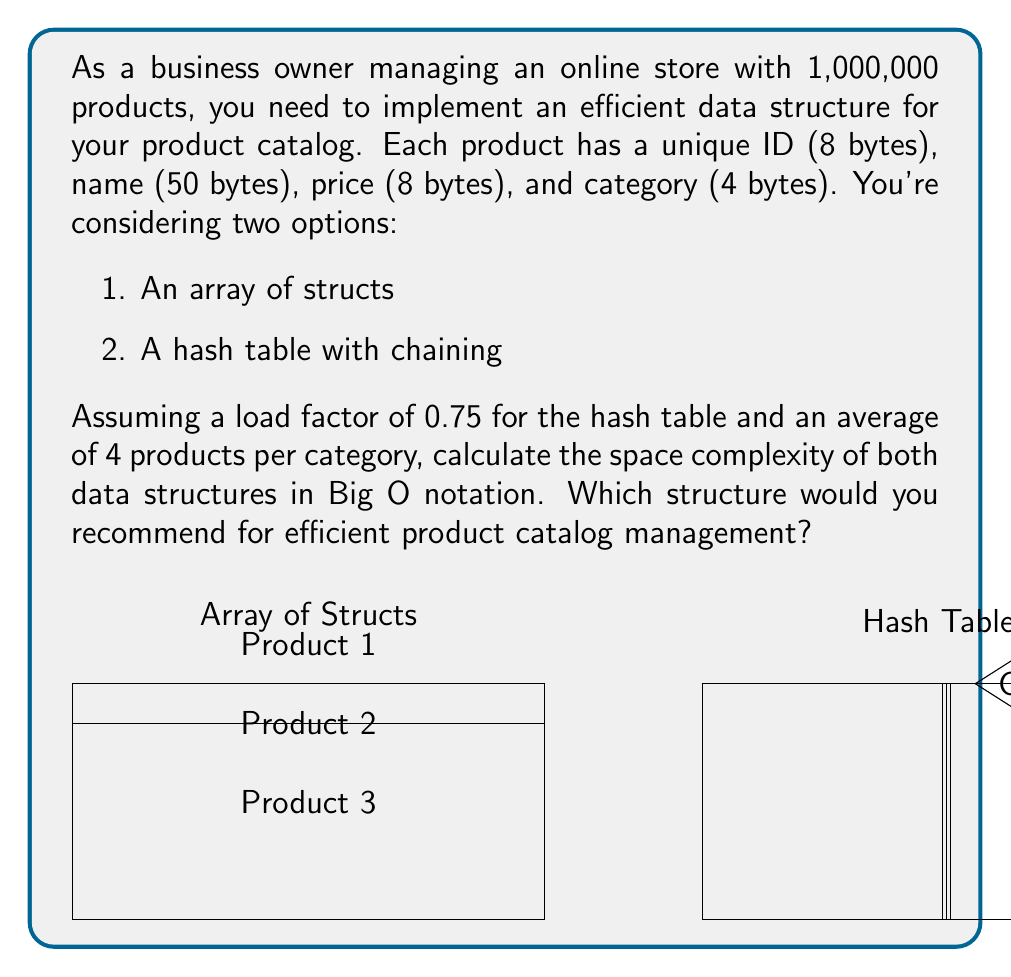Show me your answer to this math problem. Let's analyze the space complexity of both data structures:

1. Array of Structs:
   - Each product requires: 8 + 50 + 8 + 4 = 70 bytes
   - For 1,000,000 products: 70 * 1,000,000 = 70,000,000 bytes
   - Space complexity: $O(n)$, where n is the number of products

2. Hash Table with Chaining:
   - Hash table size: 1,000,000 / 0.75 ≈ 1,333,333 buckets
   - Each bucket is a pointer (8 bytes): 8 * 1,333,333 = 10,666,664 bytes
   - Product data: 70 * 1,000,000 = 70,000,000 bytes
   - Total: 10,666,664 + 70,000,000 = 80,666,664 bytes
   - Space complexity: $O(n)$, where n is the number of products

Both data structures have a space complexity of $O(n)$. However, the hash table requires slightly more space due to the additional pointers for chaining.

Recommendation:
Despite the slightly higher space requirement, the hash table is recommended for efficient product catalog management because:

1. It offers $O(1)$ average-case time complexity for insertions, deletions, and lookups, compared to $O(n)$ for an array.
2. It allows for efficient category-based queries by using the category as part of the hash key.
3. It provides better flexibility for adding or removing products without reorganizing the entire data structure.

The small increase in space usage is outweighed by the significant performance benefits, especially for a large catalog with frequent updates and queries.
Answer: $O(n)$ for both; recommend hash table for better time complexity and flexibility. 